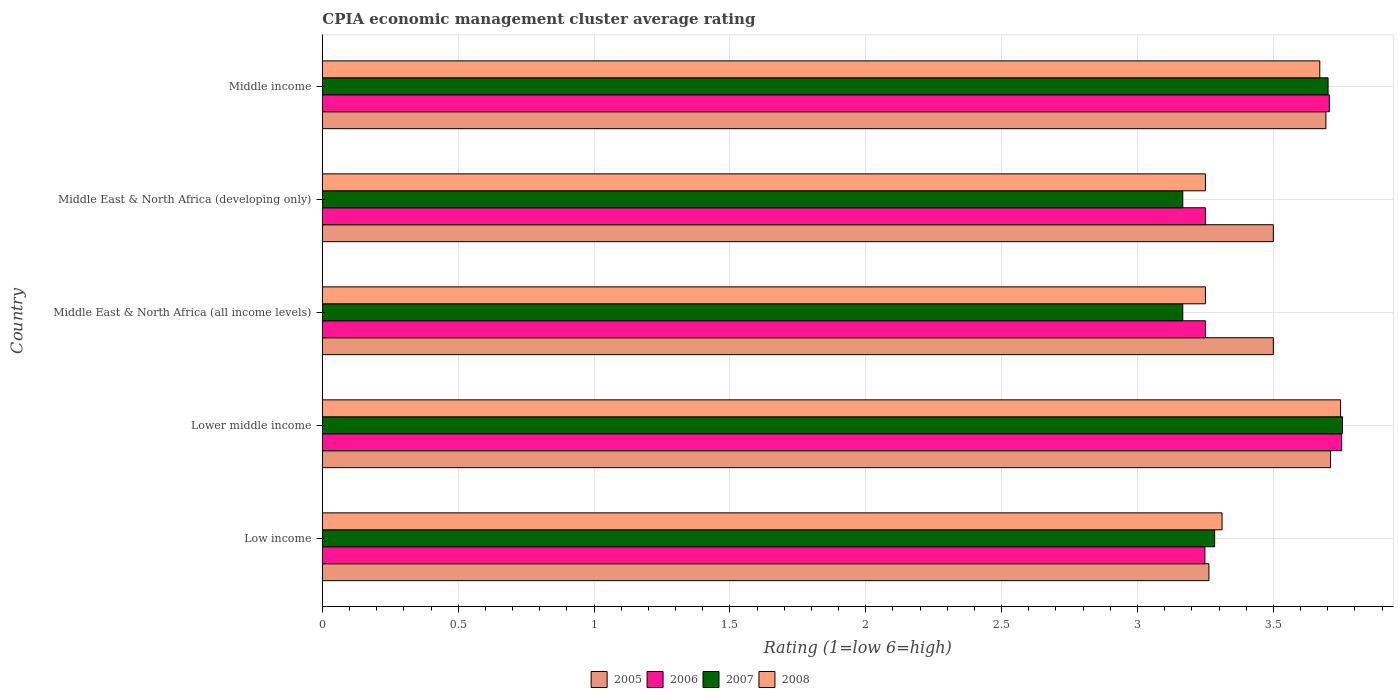How many groups of bars are there?
Give a very brief answer. 5. Are the number of bars per tick equal to the number of legend labels?
Offer a terse response. Yes. What is the label of the 4th group of bars from the top?
Your answer should be compact. Lower middle income. What is the CPIA rating in 2008 in Low income?
Your answer should be compact. 3.31. Across all countries, what is the maximum CPIA rating in 2007?
Make the answer very short. 3.75. Across all countries, what is the minimum CPIA rating in 2007?
Ensure brevity in your answer.  3.17. In which country was the CPIA rating in 2008 maximum?
Offer a terse response. Lower middle income. In which country was the CPIA rating in 2008 minimum?
Ensure brevity in your answer.  Middle East & North Africa (all income levels). What is the total CPIA rating in 2005 in the graph?
Your answer should be very brief. 17.67. What is the difference between the CPIA rating in 2008 in Middle East & North Africa (all income levels) and that in Middle income?
Your answer should be compact. -0.42. What is the difference between the CPIA rating in 2007 in Middle East & North Africa (all income levels) and the CPIA rating in 2005 in Middle East & North Africa (developing only)?
Your answer should be very brief. -0.33. What is the average CPIA rating in 2005 per country?
Your answer should be compact. 3.53. What is the difference between the CPIA rating in 2008 and CPIA rating in 2007 in Middle income?
Your answer should be very brief. -0.03. Is the CPIA rating in 2006 in Lower middle income less than that in Middle East & North Africa (developing only)?
Your answer should be very brief. No. What is the difference between the highest and the second highest CPIA rating in 2007?
Your response must be concise. 0.05. What is the difference between the highest and the lowest CPIA rating in 2008?
Your answer should be compact. 0.5. In how many countries, is the CPIA rating in 2008 greater than the average CPIA rating in 2008 taken over all countries?
Your answer should be very brief. 2. What does the 3rd bar from the top in Middle East & North Africa (all income levels) represents?
Provide a succinct answer. 2006. What does the 1st bar from the bottom in Middle income represents?
Offer a terse response. 2005. Is it the case that in every country, the sum of the CPIA rating in 2006 and CPIA rating in 2005 is greater than the CPIA rating in 2008?
Keep it short and to the point. Yes. How many bars are there?
Ensure brevity in your answer.  20. Are all the bars in the graph horizontal?
Make the answer very short. Yes. How many countries are there in the graph?
Offer a terse response. 5. Are the values on the major ticks of X-axis written in scientific E-notation?
Offer a very short reply. No. Does the graph contain any zero values?
Give a very brief answer. No. How many legend labels are there?
Make the answer very short. 4. How are the legend labels stacked?
Your answer should be compact. Horizontal. What is the title of the graph?
Offer a terse response. CPIA economic management cluster average rating. Does "1972" appear as one of the legend labels in the graph?
Provide a succinct answer. No. What is the label or title of the X-axis?
Give a very brief answer. Rating (1=low 6=high). What is the Rating (1=low 6=high) of 2005 in Low income?
Give a very brief answer. 3.26. What is the Rating (1=low 6=high) of 2006 in Low income?
Your answer should be compact. 3.25. What is the Rating (1=low 6=high) in 2007 in Low income?
Provide a succinct answer. 3.28. What is the Rating (1=low 6=high) in 2008 in Low income?
Your answer should be compact. 3.31. What is the Rating (1=low 6=high) in 2005 in Lower middle income?
Offer a terse response. 3.71. What is the Rating (1=low 6=high) of 2006 in Lower middle income?
Offer a very short reply. 3.75. What is the Rating (1=low 6=high) in 2007 in Lower middle income?
Provide a short and direct response. 3.75. What is the Rating (1=low 6=high) of 2008 in Lower middle income?
Your answer should be very brief. 3.75. What is the Rating (1=low 6=high) of 2007 in Middle East & North Africa (all income levels)?
Your answer should be compact. 3.17. What is the Rating (1=low 6=high) of 2005 in Middle East & North Africa (developing only)?
Provide a succinct answer. 3.5. What is the Rating (1=low 6=high) of 2006 in Middle East & North Africa (developing only)?
Make the answer very short. 3.25. What is the Rating (1=low 6=high) of 2007 in Middle East & North Africa (developing only)?
Your answer should be very brief. 3.17. What is the Rating (1=low 6=high) of 2005 in Middle income?
Offer a terse response. 3.69. What is the Rating (1=low 6=high) of 2006 in Middle income?
Your answer should be very brief. 3.71. What is the Rating (1=low 6=high) of 2007 in Middle income?
Your answer should be very brief. 3.7. What is the Rating (1=low 6=high) in 2008 in Middle income?
Your answer should be compact. 3.67. Across all countries, what is the maximum Rating (1=low 6=high) of 2005?
Make the answer very short. 3.71. Across all countries, what is the maximum Rating (1=low 6=high) in 2006?
Your answer should be very brief. 3.75. Across all countries, what is the maximum Rating (1=low 6=high) in 2007?
Keep it short and to the point. 3.75. Across all countries, what is the maximum Rating (1=low 6=high) in 2008?
Offer a very short reply. 3.75. Across all countries, what is the minimum Rating (1=low 6=high) of 2005?
Provide a short and direct response. 3.26. Across all countries, what is the minimum Rating (1=low 6=high) of 2006?
Your answer should be very brief. 3.25. Across all countries, what is the minimum Rating (1=low 6=high) in 2007?
Your answer should be compact. 3.17. Across all countries, what is the minimum Rating (1=low 6=high) of 2008?
Provide a short and direct response. 3.25. What is the total Rating (1=low 6=high) of 2005 in the graph?
Provide a succinct answer. 17.67. What is the total Rating (1=low 6=high) of 2006 in the graph?
Your answer should be compact. 17.21. What is the total Rating (1=low 6=high) of 2007 in the graph?
Provide a short and direct response. 17.07. What is the total Rating (1=low 6=high) in 2008 in the graph?
Keep it short and to the point. 17.23. What is the difference between the Rating (1=low 6=high) in 2005 in Low income and that in Lower middle income?
Your answer should be compact. -0.45. What is the difference between the Rating (1=low 6=high) of 2006 in Low income and that in Lower middle income?
Provide a succinct answer. -0.5. What is the difference between the Rating (1=low 6=high) of 2007 in Low income and that in Lower middle income?
Your response must be concise. -0.47. What is the difference between the Rating (1=low 6=high) of 2008 in Low income and that in Lower middle income?
Your answer should be compact. -0.44. What is the difference between the Rating (1=low 6=high) of 2005 in Low income and that in Middle East & North Africa (all income levels)?
Ensure brevity in your answer.  -0.24. What is the difference between the Rating (1=low 6=high) in 2006 in Low income and that in Middle East & North Africa (all income levels)?
Make the answer very short. -0. What is the difference between the Rating (1=low 6=high) of 2007 in Low income and that in Middle East & North Africa (all income levels)?
Ensure brevity in your answer.  0.12. What is the difference between the Rating (1=low 6=high) in 2008 in Low income and that in Middle East & North Africa (all income levels)?
Your answer should be very brief. 0.06. What is the difference between the Rating (1=low 6=high) in 2005 in Low income and that in Middle East & North Africa (developing only)?
Ensure brevity in your answer.  -0.24. What is the difference between the Rating (1=low 6=high) of 2006 in Low income and that in Middle East & North Africa (developing only)?
Your response must be concise. -0. What is the difference between the Rating (1=low 6=high) in 2007 in Low income and that in Middle East & North Africa (developing only)?
Provide a short and direct response. 0.12. What is the difference between the Rating (1=low 6=high) of 2008 in Low income and that in Middle East & North Africa (developing only)?
Your answer should be very brief. 0.06. What is the difference between the Rating (1=low 6=high) in 2005 in Low income and that in Middle income?
Give a very brief answer. -0.43. What is the difference between the Rating (1=low 6=high) of 2006 in Low income and that in Middle income?
Provide a succinct answer. -0.46. What is the difference between the Rating (1=low 6=high) of 2007 in Low income and that in Middle income?
Your answer should be compact. -0.42. What is the difference between the Rating (1=low 6=high) in 2008 in Low income and that in Middle income?
Offer a terse response. -0.36. What is the difference between the Rating (1=low 6=high) of 2005 in Lower middle income and that in Middle East & North Africa (all income levels)?
Ensure brevity in your answer.  0.21. What is the difference between the Rating (1=low 6=high) in 2006 in Lower middle income and that in Middle East & North Africa (all income levels)?
Your answer should be compact. 0.5. What is the difference between the Rating (1=low 6=high) of 2007 in Lower middle income and that in Middle East & North Africa (all income levels)?
Your answer should be compact. 0.59. What is the difference between the Rating (1=low 6=high) of 2008 in Lower middle income and that in Middle East & North Africa (all income levels)?
Keep it short and to the point. 0.5. What is the difference between the Rating (1=low 6=high) of 2005 in Lower middle income and that in Middle East & North Africa (developing only)?
Provide a short and direct response. 0.21. What is the difference between the Rating (1=low 6=high) in 2006 in Lower middle income and that in Middle East & North Africa (developing only)?
Provide a short and direct response. 0.5. What is the difference between the Rating (1=low 6=high) of 2007 in Lower middle income and that in Middle East & North Africa (developing only)?
Your response must be concise. 0.59. What is the difference between the Rating (1=low 6=high) in 2008 in Lower middle income and that in Middle East & North Africa (developing only)?
Your answer should be very brief. 0.5. What is the difference between the Rating (1=low 6=high) in 2005 in Lower middle income and that in Middle income?
Make the answer very short. 0.02. What is the difference between the Rating (1=low 6=high) of 2006 in Lower middle income and that in Middle income?
Offer a terse response. 0.05. What is the difference between the Rating (1=low 6=high) of 2007 in Lower middle income and that in Middle income?
Your answer should be very brief. 0.05. What is the difference between the Rating (1=low 6=high) of 2008 in Lower middle income and that in Middle income?
Provide a short and direct response. 0.08. What is the difference between the Rating (1=low 6=high) of 2008 in Middle East & North Africa (all income levels) and that in Middle East & North Africa (developing only)?
Your answer should be compact. 0. What is the difference between the Rating (1=low 6=high) in 2005 in Middle East & North Africa (all income levels) and that in Middle income?
Give a very brief answer. -0.19. What is the difference between the Rating (1=low 6=high) in 2006 in Middle East & North Africa (all income levels) and that in Middle income?
Make the answer very short. -0.46. What is the difference between the Rating (1=low 6=high) in 2007 in Middle East & North Africa (all income levels) and that in Middle income?
Offer a very short reply. -0.53. What is the difference between the Rating (1=low 6=high) of 2008 in Middle East & North Africa (all income levels) and that in Middle income?
Your answer should be very brief. -0.42. What is the difference between the Rating (1=low 6=high) in 2005 in Middle East & North Africa (developing only) and that in Middle income?
Offer a very short reply. -0.19. What is the difference between the Rating (1=low 6=high) of 2006 in Middle East & North Africa (developing only) and that in Middle income?
Offer a very short reply. -0.46. What is the difference between the Rating (1=low 6=high) of 2007 in Middle East & North Africa (developing only) and that in Middle income?
Make the answer very short. -0.53. What is the difference between the Rating (1=low 6=high) of 2008 in Middle East & North Africa (developing only) and that in Middle income?
Your answer should be very brief. -0.42. What is the difference between the Rating (1=low 6=high) in 2005 in Low income and the Rating (1=low 6=high) in 2006 in Lower middle income?
Provide a short and direct response. -0.49. What is the difference between the Rating (1=low 6=high) in 2005 in Low income and the Rating (1=low 6=high) in 2007 in Lower middle income?
Make the answer very short. -0.49. What is the difference between the Rating (1=low 6=high) of 2005 in Low income and the Rating (1=low 6=high) of 2008 in Lower middle income?
Give a very brief answer. -0.48. What is the difference between the Rating (1=low 6=high) in 2006 in Low income and the Rating (1=low 6=high) in 2007 in Lower middle income?
Make the answer very short. -0.51. What is the difference between the Rating (1=low 6=high) in 2006 in Low income and the Rating (1=low 6=high) in 2008 in Lower middle income?
Make the answer very short. -0.5. What is the difference between the Rating (1=low 6=high) in 2007 in Low income and the Rating (1=low 6=high) in 2008 in Lower middle income?
Your answer should be compact. -0.46. What is the difference between the Rating (1=low 6=high) of 2005 in Low income and the Rating (1=low 6=high) of 2006 in Middle East & North Africa (all income levels)?
Ensure brevity in your answer.  0.01. What is the difference between the Rating (1=low 6=high) of 2005 in Low income and the Rating (1=low 6=high) of 2007 in Middle East & North Africa (all income levels)?
Offer a terse response. 0.1. What is the difference between the Rating (1=low 6=high) of 2005 in Low income and the Rating (1=low 6=high) of 2008 in Middle East & North Africa (all income levels)?
Offer a terse response. 0.01. What is the difference between the Rating (1=low 6=high) of 2006 in Low income and the Rating (1=low 6=high) of 2007 in Middle East & North Africa (all income levels)?
Provide a succinct answer. 0.08. What is the difference between the Rating (1=low 6=high) of 2006 in Low income and the Rating (1=low 6=high) of 2008 in Middle East & North Africa (all income levels)?
Your answer should be compact. -0. What is the difference between the Rating (1=low 6=high) in 2007 in Low income and the Rating (1=low 6=high) in 2008 in Middle East & North Africa (all income levels)?
Your response must be concise. 0.03. What is the difference between the Rating (1=low 6=high) in 2005 in Low income and the Rating (1=low 6=high) in 2006 in Middle East & North Africa (developing only)?
Give a very brief answer. 0.01. What is the difference between the Rating (1=low 6=high) of 2005 in Low income and the Rating (1=low 6=high) of 2007 in Middle East & North Africa (developing only)?
Give a very brief answer. 0.1. What is the difference between the Rating (1=low 6=high) in 2005 in Low income and the Rating (1=low 6=high) in 2008 in Middle East & North Africa (developing only)?
Offer a terse response. 0.01. What is the difference between the Rating (1=low 6=high) in 2006 in Low income and the Rating (1=low 6=high) in 2007 in Middle East & North Africa (developing only)?
Provide a short and direct response. 0.08. What is the difference between the Rating (1=low 6=high) in 2006 in Low income and the Rating (1=low 6=high) in 2008 in Middle East & North Africa (developing only)?
Offer a very short reply. -0. What is the difference between the Rating (1=low 6=high) of 2007 in Low income and the Rating (1=low 6=high) of 2008 in Middle East & North Africa (developing only)?
Give a very brief answer. 0.03. What is the difference between the Rating (1=low 6=high) of 2005 in Low income and the Rating (1=low 6=high) of 2006 in Middle income?
Your answer should be very brief. -0.44. What is the difference between the Rating (1=low 6=high) in 2005 in Low income and the Rating (1=low 6=high) in 2007 in Middle income?
Your answer should be very brief. -0.44. What is the difference between the Rating (1=low 6=high) in 2005 in Low income and the Rating (1=low 6=high) in 2008 in Middle income?
Keep it short and to the point. -0.41. What is the difference between the Rating (1=low 6=high) of 2006 in Low income and the Rating (1=low 6=high) of 2007 in Middle income?
Your answer should be compact. -0.45. What is the difference between the Rating (1=low 6=high) in 2006 in Low income and the Rating (1=low 6=high) in 2008 in Middle income?
Offer a terse response. -0.42. What is the difference between the Rating (1=low 6=high) of 2007 in Low income and the Rating (1=low 6=high) of 2008 in Middle income?
Provide a succinct answer. -0.39. What is the difference between the Rating (1=low 6=high) of 2005 in Lower middle income and the Rating (1=low 6=high) of 2006 in Middle East & North Africa (all income levels)?
Your answer should be compact. 0.46. What is the difference between the Rating (1=low 6=high) in 2005 in Lower middle income and the Rating (1=low 6=high) in 2007 in Middle East & North Africa (all income levels)?
Your answer should be very brief. 0.54. What is the difference between the Rating (1=low 6=high) in 2005 in Lower middle income and the Rating (1=low 6=high) in 2008 in Middle East & North Africa (all income levels)?
Your answer should be compact. 0.46. What is the difference between the Rating (1=low 6=high) in 2006 in Lower middle income and the Rating (1=low 6=high) in 2007 in Middle East & North Africa (all income levels)?
Keep it short and to the point. 0.58. What is the difference between the Rating (1=low 6=high) of 2006 in Lower middle income and the Rating (1=low 6=high) of 2008 in Middle East & North Africa (all income levels)?
Keep it short and to the point. 0.5. What is the difference between the Rating (1=low 6=high) in 2007 in Lower middle income and the Rating (1=low 6=high) in 2008 in Middle East & North Africa (all income levels)?
Your response must be concise. 0.5. What is the difference between the Rating (1=low 6=high) in 2005 in Lower middle income and the Rating (1=low 6=high) in 2006 in Middle East & North Africa (developing only)?
Ensure brevity in your answer.  0.46. What is the difference between the Rating (1=low 6=high) of 2005 in Lower middle income and the Rating (1=low 6=high) of 2007 in Middle East & North Africa (developing only)?
Keep it short and to the point. 0.54. What is the difference between the Rating (1=low 6=high) of 2005 in Lower middle income and the Rating (1=low 6=high) of 2008 in Middle East & North Africa (developing only)?
Your answer should be compact. 0.46. What is the difference between the Rating (1=low 6=high) of 2006 in Lower middle income and the Rating (1=low 6=high) of 2007 in Middle East & North Africa (developing only)?
Ensure brevity in your answer.  0.58. What is the difference between the Rating (1=low 6=high) of 2006 in Lower middle income and the Rating (1=low 6=high) of 2008 in Middle East & North Africa (developing only)?
Give a very brief answer. 0.5. What is the difference between the Rating (1=low 6=high) of 2007 in Lower middle income and the Rating (1=low 6=high) of 2008 in Middle East & North Africa (developing only)?
Make the answer very short. 0.5. What is the difference between the Rating (1=low 6=high) in 2005 in Lower middle income and the Rating (1=low 6=high) in 2006 in Middle income?
Ensure brevity in your answer.  0. What is the difference between the Rating (1=low 6=high) in 2005 in Lower middle income and the Rating (1=low 6=high) in 2007 in Middle income?
Your response must be concise. 0.01. What is the difference between the Rating (1=low 6=high) of 2005 in Lower middle income and the Rating (1=low 6=high) of 2008 in Middle income?
Keep it short and to the point. 0.04. What is the difference between the Rating (1=low 6=high) of 2006 in Lower middle income and the Rating (1=low 6=high) of 2007 in Middle income?
Offer a terse response. 0.05. What is the difference between the Rating (1=low 6=high) in 2006 in Lower middle income and the Rating (1=low 6=high) in 2008 in Middle income?
Offer a very short reply. 0.08. What is the difference between the Rating (1=low 6=high) in 2007 in Lower middle income and the Rating (1=low 6=high) in 2008 in Middle income?
Keep it short and to the point. 0.08. What is the difference between the Rating (1=low 6=high) in 2005 in Middle East & North Africa (all income levels) and the Rating (1=low 6=high) in 2006 in Middle East & North Africa (developing only)?
Provide a short and direct response. 0.25. What is the difference between the Rating (1=low 6=high) in 2005 in Middle East & North Africa (all income levels) and the Rating (1=low 6=high) in 2007 in Middle East & North Africa (developing only)?
Your answer should be very brief. 0.33. What is the difference between the Rating (1=low 6=high) of 2006 in Middle East & North Africa (all income levels) and the Rating (1=low 6=high) of 2007 in Middle East & North Africa (developing only)?
Offer a very short reply. 0.08. What is the difference between the Rating (1=low 6=high) in 2007 in Middle East & North Africa (all income levels) and the Rating (1=low 6=high) in 2008 in Middle East & North Africa (developing only)?
Make the answer very short. -0.08. What is the difference between the Rating (1=low 6=high) of 2005 in Middle East & North Africa (all income levels) and the Rating (1=low 6=high) of 2006 in Middle income?
Your answer should be very brief. -0.21. What is the difference between the Rating (1=low 6=high) in 2005 in Middle East & North Africa (all income levels) and the Rating (1=low 6=high) in 2007 in Middle income?
Provide a succinct answer. -0.2. What is the difference between the Rating (1=low 6=high) in 2005 in Middle East & North Africa (all income levels) and the Rating (1=low 6=high) in 2008 in Middle income?
Your response must be concise. -0.17. What is the difference between the Rating (1=low 6=high) in 2006 in Middle East & North Africa (all income levels) and the Rating (1=low 6=high) in 2007 in Middle income?
Your answer should be compact. -0.45. What is the difference between the Rating (1=low 6=high) in 2006 in Middle East & North Africa (all income levels) and the Rating (1=low 6=high) in 2008 in Middle income?
Ensure brevity in your answer.  -0.42. What is the difference between the Rating (1=low 6=high) of 2007 in Middle East & North Africa (all income levels) and the Rating (1=low 6=high) of 2008 in Middle income?
Make the answer very short. -0.5. What is the difference between the Rating (1=low 6=high) of 2005 in Middle East & North Africa (developing only) and the Rating (1=low 6=high) of 2006 in Middle income?
Keep it short and to the point. -0.21. What is the difference between the Rating (1=low 6=high) in 2005 in Middle East & North Africa (developing only) and the Rating (1=low 6=high) in 2007 in Middle income?
Offer a very short reply. -0.2. What is the difference between the Rating (1=low 6=high) of 2005 in Middle East & North Africa (developing only) and the Rating (1=low 6=high) of 2008 in Middle income?
Your response must be concise. -0.17. What is the difference between the Rating (1=low 6=high) of 2006 in Middle East & North Africa (developing only) and the Rating (1=low 6=high) of 2007 in Middle income?
Your answer should be compact. -0.45. What is the difference between the Rating (1=low 6=high) in 2006 in Middle East & North Africa (developing only) and the Rating (1=low 6=high) in 2008 in Middle income?
Make the answer very short. -0.42. What is the difference between the Rating (1=low 6=high) of 2007 in Middle East & North Africa (developing only) and the Rating (1=low 6=high) of 2008 in Middle income?
Offer a terse response. -0.5. What is the average Rating (1=low 6=high) in 2005 per country?
Ensure brevity in your answer.  3.53. What is the average Rating (1=low 6=high) in 2006 per country?
Make the answer very short. 3.44. What is the average Rating (1=low 6=high) of 2007 per country?
Ensure brevity in your answer.  3.41. What is the average Rating (1=low 6=high) of 2008 per country?
Ensure brevity in your answer.  3.45. What is the difference between the Rating (1=low 6=high) of 2005 and Rating (1=low 6=high) of 2006 in Low income?
Offer a terse response. 0.01. What is the difference between the Rating (1=low 6=high) in 2005 and Rating (1=low 6=high) in 2007 in Low income?
Give a very brief answer. -0.02. What is the difference between the Rating (1=low 6=high) in 2005 and Rating (1=low 6=high) in 2008 in Low income?
Offer a terse response. -0.05. What is the difference between the Rating (1=low 6=high) of 2006 and Rating (1=low 6=high) of 2007 in Low income?
Ensure brevity in your answer.  -0.04. What is the difference between the Rating (1=low 6=high) of 2006 and Rating (1=low 6=high) of 2008 in Low income?
Provide a succinct answer. -0.06. What is the difference between the Rating (1=low 6=high) in 2007 and Rating (1=low 6=high) in 2008 in Low income?
Your answer should be very brief. -0.03. What is the difference between the Rating (1=low 6=high) in 2005 and Rating (1=low 6=high) in 2006 in Lower middle income?
Give a very brief answer. -0.04. What is the difference between the Rating (1=low 6=high) of 2005 and Rating (1=low 6=high) of 2007 in Lower middle income?
Provide a succinct answer. -0.04. What is the difference between the Rating (1=low 6=high) in 2005 and Rating (1=low 6=high) in 2008 in Lower middle income?
Give a very brief answer. -0.04. What is the difference between the Rating (1=low 6=high) of 2006 and Rating (1=low 6=high) of 2007 in Lower middle income?
Keep it short and to the point. -0. What is the difference between the Rating (1=low 6=high) of 2006 and Rating (1=low 6=high) of 2008 in Lower middle income?
Offer a terse response. 0. What is the difference between the Rating (1=low 6=high) of 2007 and Rating (1=low 6=high) of 2008 in Lower middle income?
Provide a succinct answer. 0.01. What is the difference between the Rating (1=low 6=high) in 2005 and Rating (1=low 6=high) in 2008 in Middle East & North Africa (all income levels)?
Give a very brief answer. 0.25. What is the difference between the Rating (1=low 6=high) of 2006 and Rating (1=low 6=high) of 2007 in Middle East & North Africa (all income levels)?
Offer a terse response. 0.08. What is the difference between the Rating (1=low 6=high) in 2007 and Rating (1=low 6=high) in 2008 in Middle East & North Africa (all income levels)?
Give a very brief answer. -0.08. What is the difference between the Rating (1=low 6=high) of 2005 and Rating (1=low 6=high) of 2008 in Middle East & North Africa (developing only)?
Your answer should be very brief. 0.25. What is the difference between the Rating (1=low 6=high) in 2006 and Rating (1=low 6=high) in 2007 in Middle East & North Africa (developing only)?
Your answer should be very brief. 0.08. What is the difference between the Rating (1=low 6=high) of 2007 and Rating (1=low 6=high) of 2008 in Middle East & North Africa (developing only)?
Your answer should be compact. -0.08. What is the difference between the Rating (1=low 6=high) in 2005 and Rating (1=low 6=high) in 2006 in Middle income?
Offer a very short reply. -0.01. What is the difference between the Rating (1=low 6=high) in 2005 and Rating (1=low 6=high) in 2007 in Middle income?
Provide a succinct answer. -0.01. What is the difference between the Rating (1=low 6=high) in 2005 and Rating (1=low 6=high) in 2008 in Middle income?
Offer a terse response. 0.02. What is the difference between the Rating (1=low 6=high) in 2006 and Rating (1=low 6=high) in 2007 in Middle income?
Keep it short and to the point. 0. What is the difference between the Rating (1=low 6=high) in 2006 and Rating (1=low 6=high) in 2008 in Middle income?
Keep it short and to the point. 0.04. What is the difference between the Rating (1=low 6=high) in 2007 and Rating (1=low 6=high) in 2008 in Middle income?
Your answer should be very brief. 0.03. What is the ratio of the Rating (1=low 6=high) in 2005 in Low income to that in Lower middle income?
Give a very brief answer. 0.88. What is the ratio of the Rating (1=low 6=high) in 2006 in Low income to that in Lower middle income?
Provide a succinct answer. 0.87. What is the ratio of the Rating (1=low 6=high) in 2007 in Low income to that in Lower middle income?
Offer a very short reply. 0.87. What is the ratio of the Rating (1=low 6=high) in 2008 in Low income to that in Lower middle income?
Give a very brief answer. 0.88. What is the ratio of the Rating (1=low 6=high) of 2005 in Low income to that in Middle East & North Africa (all income levels)?
Your answer should be compact. 0.93. What is the ratio of the Rating (1=low 6=high) in 2006 in Low income to that in Middle East & North Africa (all income levels)?
Offer a terse response. 1. What is the ratio of the Rating (1=low 6=high) in 2008 in Low income to that in Middle East & North Africa (all income levels)?
Offer a terse response. 1.02. What is the ratio of the Rating (1=low 6=high) in 2005 in Low income to that in Middle East & North Africa (developing only)?
Your answer should be compact. 0.93. What is the ratio of the Rating (1=low 6=high) of 2008 in Low income to that in Middle East & North Africa (developing only)?
Your answer should be compact. 1.02. What is the ratio of the Rating (1=low 6=high) of 2005 in Low income to that in Middle income?
Offer a terse response. 0.88. What is the ratio of the Rating (1=low 6=high) in 2006 in Low income to that in Middle income?
Make the answer very short. 0.88. What is the ratio of the Rating (1=low 6=high) in 2007 in Low income to that in Middle income?
Offer a very short reply. 0.89. What is the ratio of the Rating (1=low 6=high) of 2008 in Low income to that in Middle income?
Keep it short and to the point. 0.9. What is the ratio of the Rating (1=low 6=high) in 2005 in Lower middle income to that in Middle East & North Africa (all income levels)?
Provide a succinct answer. 1.06. What is the ratio of the Rating (1=low 6=high) in 2006 in Lower middle income to that in Middle East & North Africa (all income levels)?
Ensure brevity in your answer.  1.15. What is the ratio of the Rating (1=low 6=high) in 2007 in Lower middle income to that in Middle East & North Africa (all income levels)?
Ensure brevity in your answer.  1.19. What is the ratio of the Rating (1=low 6=high) of 2008 in Lower middle income to that in Middle East & North Africa (all income levels)?
Ensure brevity in your answer.  1.15. What is the ratio of the Rating (1=low 6=high) of 2005 in Lower middle income to that in Middle East & North Africa (developing only)?
Offer a terse response. 1.06. What is the ratio of the Rating (1=low 6=high) of 2006 in Lower middle income to that in Middle East & North Africa (developing only)?
Offer a very short reply. 1.15. What is the ratio of the Rating (1=low 6=high) of 2007 in Lower middle income to that in Middle East & North Africa (developing only)?
Keep it short and to the point. 1.19. What is the ratio of the Rating (1=low 6=high) of 2008 in Lower middle income to that in Middle East & North Africa (developing only)?
Your response must be concise. 1.15. What is the ratio of the Rating (1=low 6=high) of 2005 in Lower middle income to that in Middle income?
Offer a terse response. 1. What is the ratio of the Rating (1=low 6=high) in 2006 in Lower middle income to that in Middle income?
Make the answer very short. 1.01. What is the ratio of the Rating (1=low 6=high) in 2007 in Lower middle income to that in Middle income?
Provide a succinct answer. 1.01. What is the ratio of the Rating (1=low 6=high) in 2008 in Lower middle income to that in Middle income?
Provide a succinct answer. 1.02. What is the ratio of the Rating (1=low 6=high) in 2005 in Middle East & North Africa (all income levels) to that in Middle East & North Africa (developing only)?
Make the answer very short. 1. What is the ratio of the Rating (1=low 6=high) of 2006 in Middle East & North Africa (all income levels) to that in Middle East & North Africa (developing only)?
Offer a terse response. 1. What is the ratio of the Rating (1=low 6=high) of 2007 in Middle East & North Africa (all income levels) to that in Middle East & North Africa (developing only)?
Ensure brevity in your answer.  1. What is the ratio of the Rating (1=low 6=high) in 2005 in Middle East & North Africa (all income levels) to that in Middle income?
Ensure brevity in your answer.  0.95. What is the ratio of the Rating (1=low 6=high) of 2006 in Middle East & North Africa (all income levels) to that in Middle income?
Your answer should be compact. 0.88. What is the ratio of the Rating (1=low 6=high) of 2007 in Middle East & North Africa (all income levels) to that in Middle income?
Make the answer very short. 0.86. What is the ratio of the Rating (1=low 6=high) of 2008 in Middle East & North Africa (all income levels) to that in Middle income?
Your answer should be compact. 0.89. What is the ratio of the Rating (1=low 6=high) in 2005 in Middle East & North Africa (developing only) to that in Middle income?
Offer a terse response. 0.95. What is the ratio of the Rating (1=low 6=high) in 2006 in Middle East & North Africa (developing only) to that in Middle income?
Ensure brevity in your answer.  0.88. What is the ratio of the Rating (1=low 6=high) in 2007 in Middle East & North Africa (developing only) to that in Middle income?
Give a very brief answer. 0.86. What is the ratio of the Rating (1=low 6=high) of 2008 in Middle East & North Africa (developing only) to that in Middle income?
Provide a succinct answer. 0.89. What is the difference between the highest and the second highest Rating (1=low 6=high) in 2005?
Your answer should be compact. 0.02. What is the difference between the highest and the second highest Rating (1=low 6=high) in 2006?
Keep it short and to the point. 0.05. What is the difference between the highest and the second highest Rating (1=low 6=high) in 2007?
Your answer should be very brief. 0.05. What is the difference between the highest and the second highest Rating (1=low 6=high) in 2008?
Offer a very short reply. 0.08. What is the difference between the highest and the lowest Rating (1=low 6=high) of 2005?
Offer a terse response. 0.45. What is the difference between the highest and the lowest Rating (1=low 6=high) in 2006?
Provide a succinct answer. 0.5. What is the difference between the highest and the lowest Rating (1=low 6=high) in 2007?
Make the answer very short. 0.59. What is the difference between the highest and the lowest Rating (1=low 6=high) in 2008?
Provide a succinct answer. 0.5. 